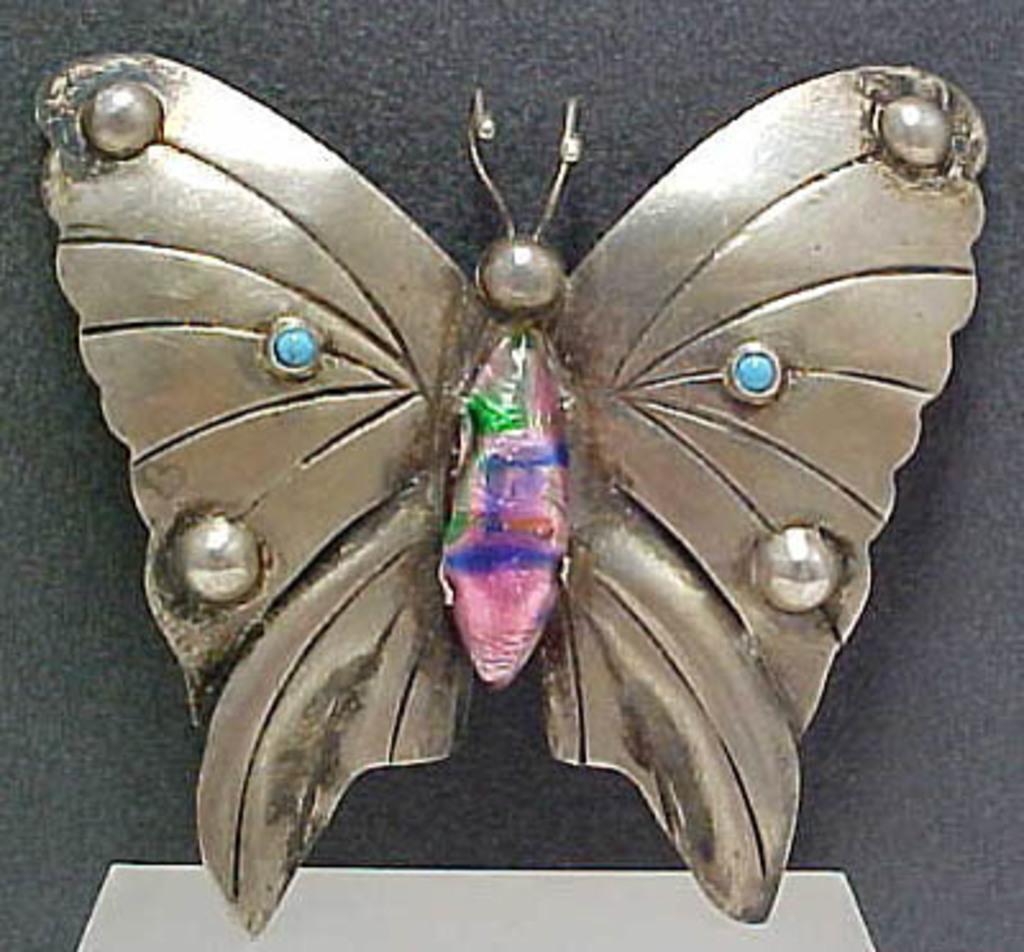In one or two sentences, can you explain what this image depicts? In this image I can see a butterfly which is made up of metal which blue, purple, pink, green and brown in color. I can see the black colored background. 